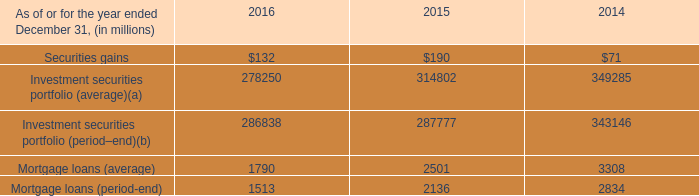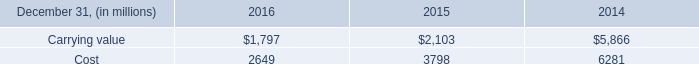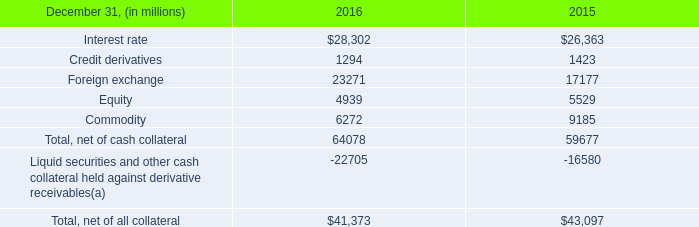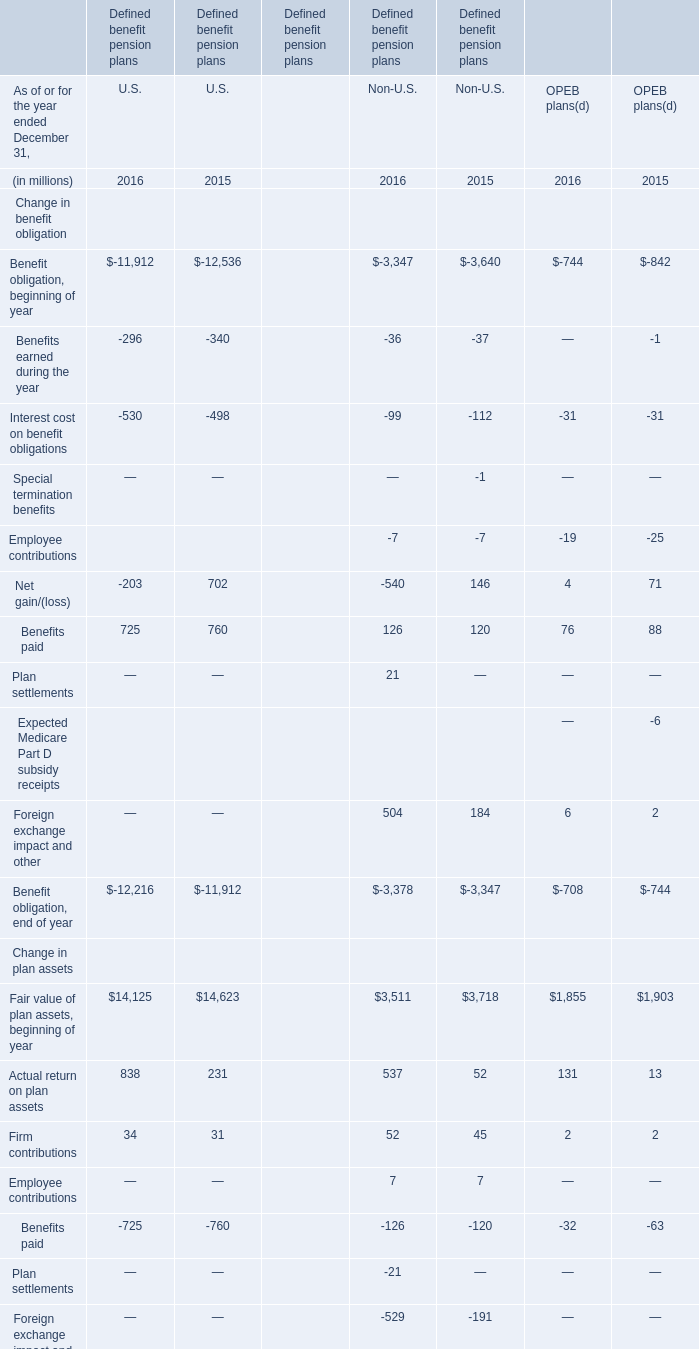what was the ratio of the avg exposure compared with derivative receivables , net of all collateral in 2016 
Computations: (31.1 / 41.4)
Answer: 0.75121. 